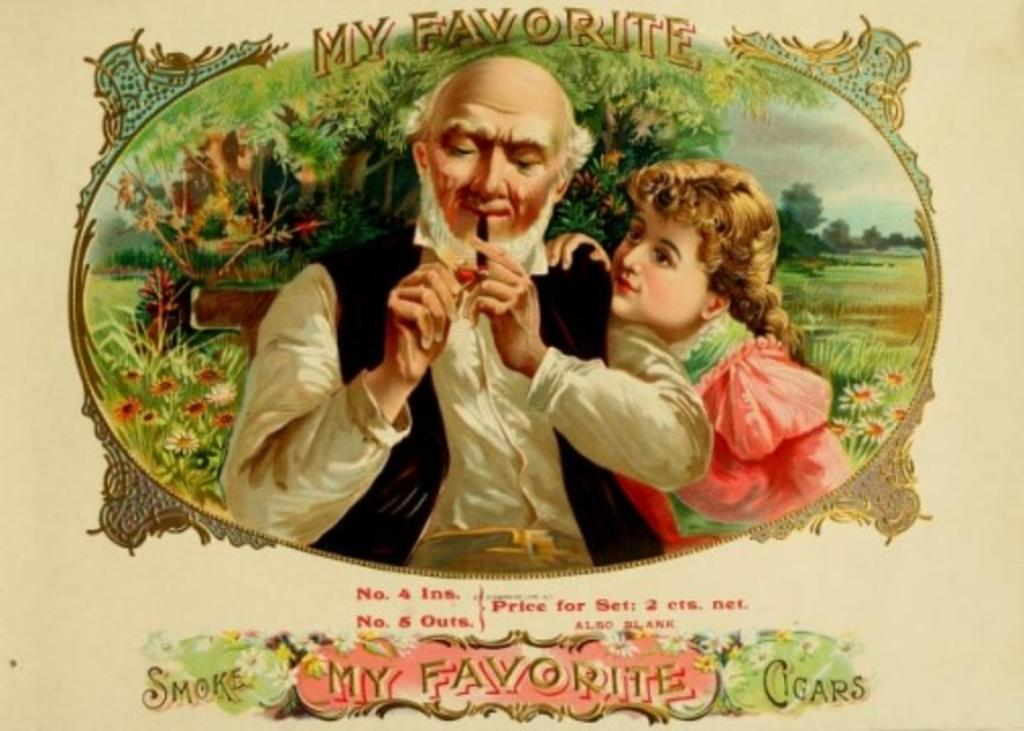Provide a one-sentence caption for the provided image. an old man smoking a tobacco pipe with the words 'my favorite' above him. 